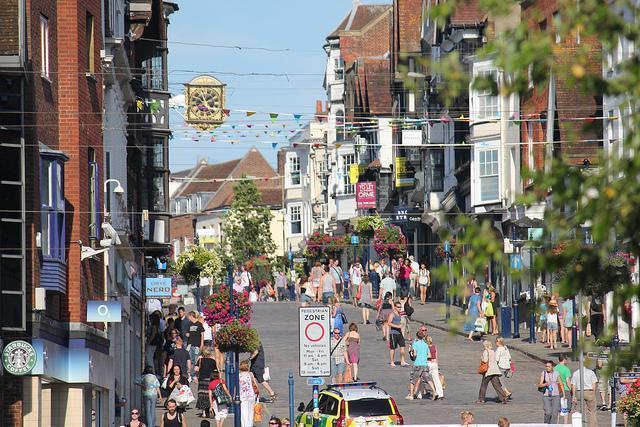What setting is this?
Choose the right answer from the provided options to respond to the question.
Options: Desert, countryside, city, tundra. City. 